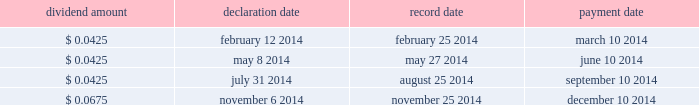Overview we finance our operations and capital expenditures through a combination of internally generated cash from operations and from borrowings under our senior secured asset-based revolving credit facility .
We believe that our current sources of funds will be sufficient to fund our cash operating requirements for the next year .
In addition , we believe that , in spite of the uncertainty of future macroeconomic conditions , we have adequate sources of liquidity and funding available to meet our longer-term needs .
However , there are a number of factors that may negatively impact our available sources of funds .
The amount of cash generated from operations will be dependent upon factors such as the successful execution of our business plan and general economic conditions .
Long-term debt activities during the year ended december 31 , 2014 , we had significant debt refinancings .
In connection with these refinancings , we recorded a loss on extinguishment of long-term debt of $ 90.7 million in our consolidated statement of operations for the year ended december 31 , 2014 .
See note 7 to the accompanying audited consolidated financial statements included elsewhere in this report for additional details .
Share repurchase program on november 6 , 2014 , we announced that our board of directors approved a $ 500 million share repurchase program effective immediately under which we may repurchase shares of our common stock in the open market or through privately negotiated transactions , depending on share price , market conditions and other factors .
The share repurchase program does not obligate us to repurchase any dollar amount or number of shares , and repurchases may be commenced or suspended from time to time without prior notice .
As of the date of this filing , no shares have been repurchased under the share repurchase program .
Dividends a summary of 2014 dividend activity for our common stock is shown below: .
On february 10 , 2015 , we announced that our board of directors declared a quarterly cash dividend on our common stock of $ 0.0675 per share .
The dividend will be paid on march 10 , 2015 to all stockholders of record as of the close of business on february 25 , 2015 .
The payment of any future dividends will be at the discretion of our board of directors and will depend upon our results of operations , financial condition , business prospects , capital requirements , contractual restrictions , any potential indebtedness we may incur , restrictions imposed by applicable law , tax considerations and other factors that our board of directors deems relevant .
In addition , our ability to pay dividends on our common stock will be limited by restrictions on our ability to pay dividends or make distributions to our stockholders and on the ability of our subsidiaries to pay dividends or make distributions to us , in each case , under the terms of our current and any future agreements governing our indebtedness .
Table of contents .
What percentage of the first quarter dividend is the fourth quarter dividend? 
Computations: (0.0675 / 0.0425)
Answer: 1.58824. 